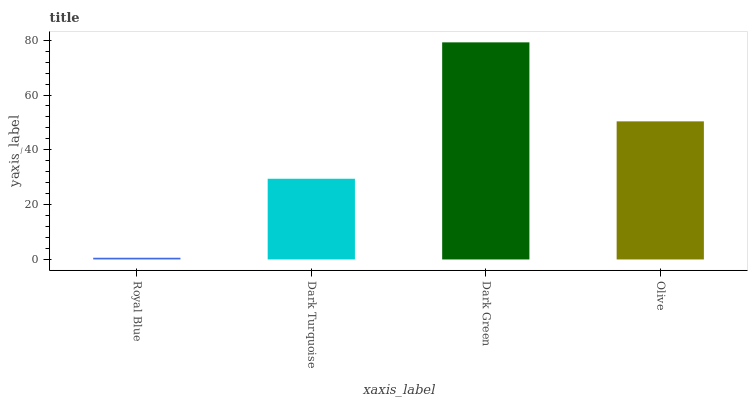Is Royal Blue the minimum?
Answer yes or no. Yes. Is Dark Green the maximum?
Answer yes or no. Yes. Is Dark Turquoise the minimum?
Answer yes or no. No. Is Dark Turquoise the maximum?
Answer yes or no. No. Is Dark Turquoise greater than Royal Blue?
Answer yes or no. Yes. Is Royal Blue less than Dark Turquoise?
Answer yes or no. Yes. Is Royal Blue greater than Dark Turquoise?
Answer yes or no. No. Is Dark Turquoise less than Royal Blue?
Answer yes or no. No. Is Olive the high median?
Answer yes or no. Yes. Is Dark Turquoise the low median?
Answer yes or no. Yes. Is Dark Turquoise the high median?
Answer yes or no. No. Is Olive the low median?
Answer yes or no. No. 